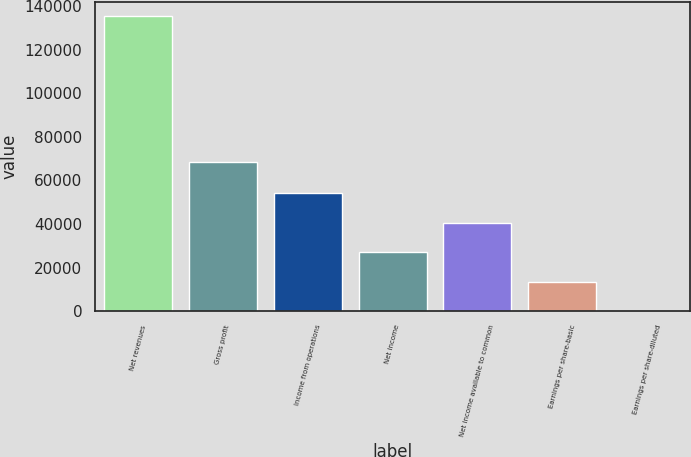Convert chart to OTSL. <chart><loc_0><loc_0><loc_500><loc_500><bar_chart><fcel>Net revenues<fcel>Gross profit<fcel>Income from operations<fcel>Net income<fcel>Net income available to common<fcel>Earnings per share-basic<fcel>Earnings per share-diluted<nl><fcel>135283<fcel>68406<fcel>54113.4<fcel>27056.8<fcel>40585.1<fcel>13528.5<fcel>0.24<nl></chart> 